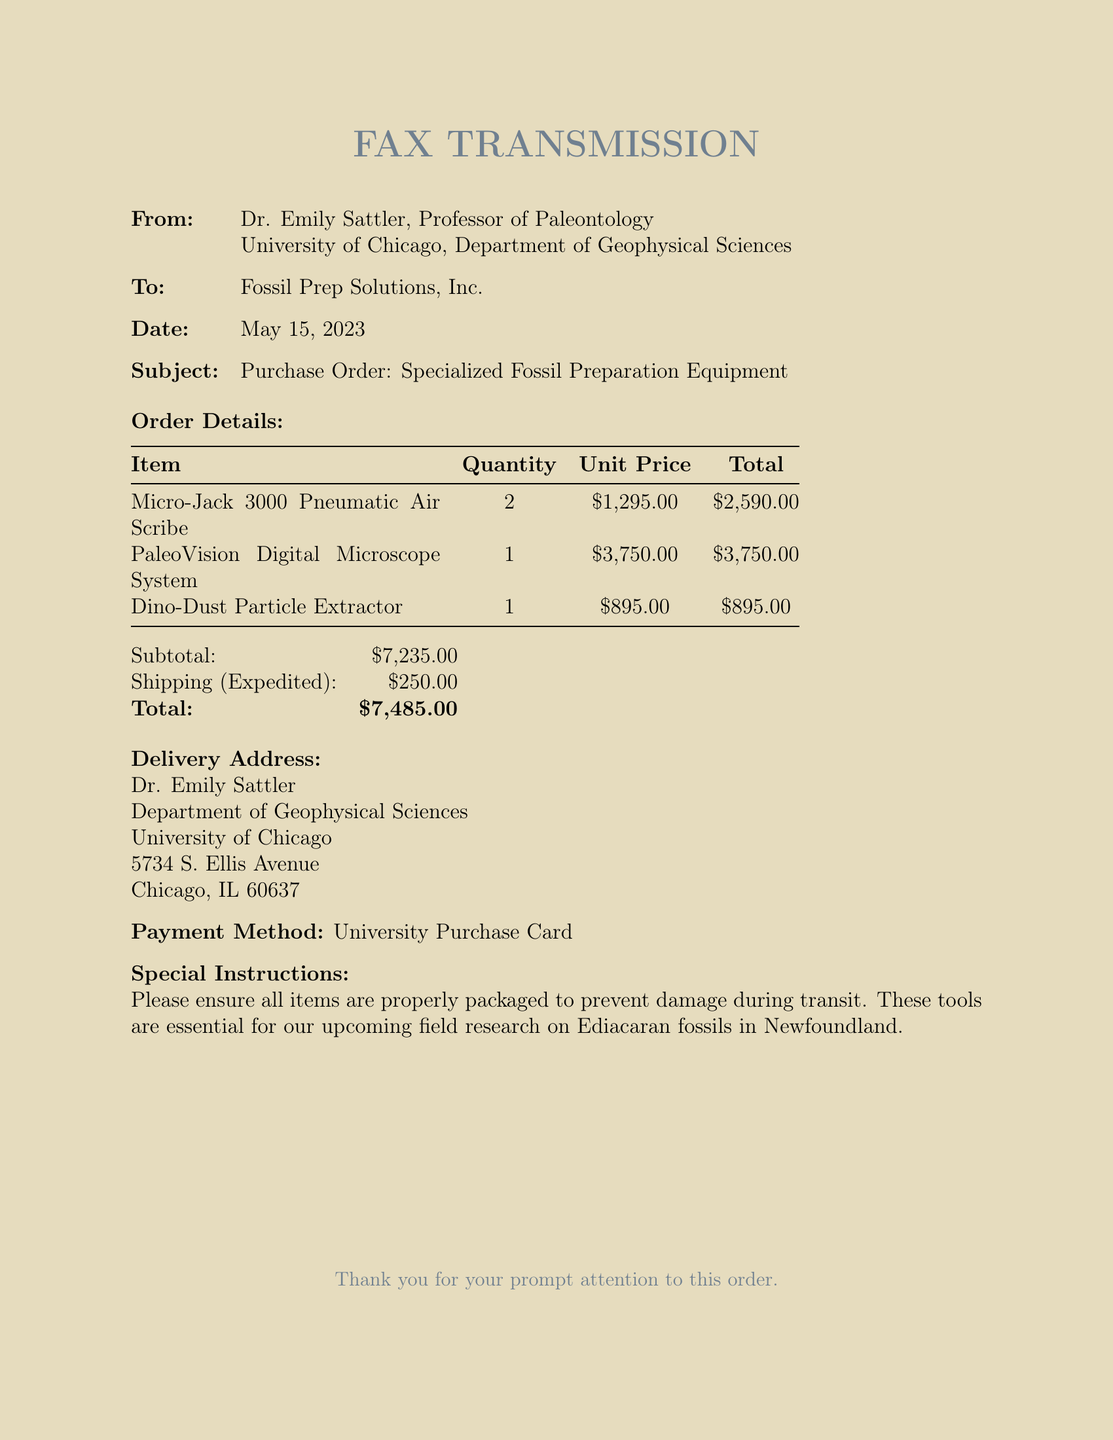What is the date of the fax? The date of the fax is provided in the document as May 15, 2023.
Answer: May 15, 2023 Who is the sender of the fax? The sender of the fax is mentioned at the beginning, identifying Dr. Emily Sattler as the Professor of Paleontology.
Answer: Dr. Emily Sattler What is the total cost of the order? The total cost is summarized at the end of the document, including the subtotal and shipping cost, resulting in the final total.
Answer: $7,485.00 How many Micro-Jack 3000 units were ordered? The document specifies the quantity of Micro-Jack 3000 Pneumatic Air Scribers ordered.
Answer: 2 What is the shipping cost for the order? The shipping cost is explicitly stated in the document following the subtotal.
Answer: $250.00 What special instruction is provided for the order? The document includes a special instruction regarding the packaging of the items to prevent damage during transit.
Answer: Properly packaged What is the payment method used for this purchase? The document specifies the payment method selected for the order.
Answer: University Purchase Card What is the delivery address for the equipment? The delivery address is listed in the document under the delivery address section.
Answer: Dr. Emily Sattler, Department of Geophysical Sciences, University of Chicago, 5734 S. Ellis Avenue, Chicago, IL 60637 What is the unit price of the PaleoVision Digital Microscope System? The unit price for the PaleoVision Digital Microscope System is detailed in the order table.
Answer: $3,750.00 